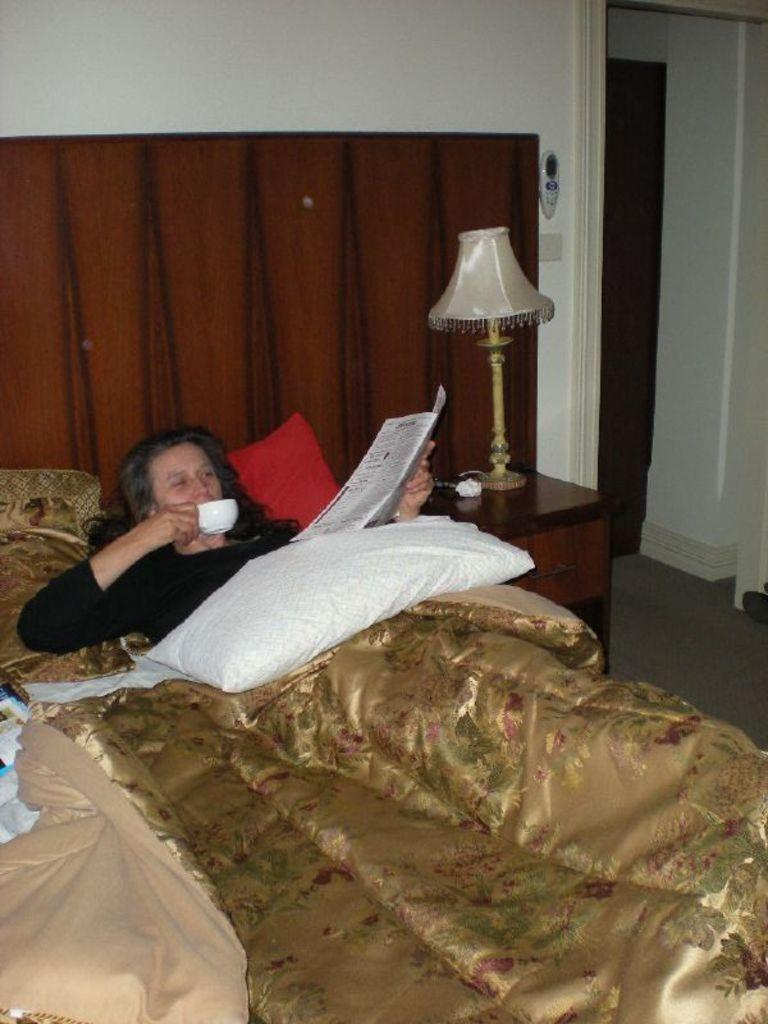Who is present in the image? There is a woman in the image. What is the woman doing in the image? The woman is sleeping on a bed, drinking coffee, and reading a newspaper. What type of furniture is present in the image? There is a wooden table in the image. What is placed on the wooden table? A table is placed on the wooden table. What type of bell can be heard ringing in the image? There is no bell present or ringing in the image. What type of mint is being used to flavor the coffee in the image? There is no mention of mint or any flavoring being used in the coffee in the image. 